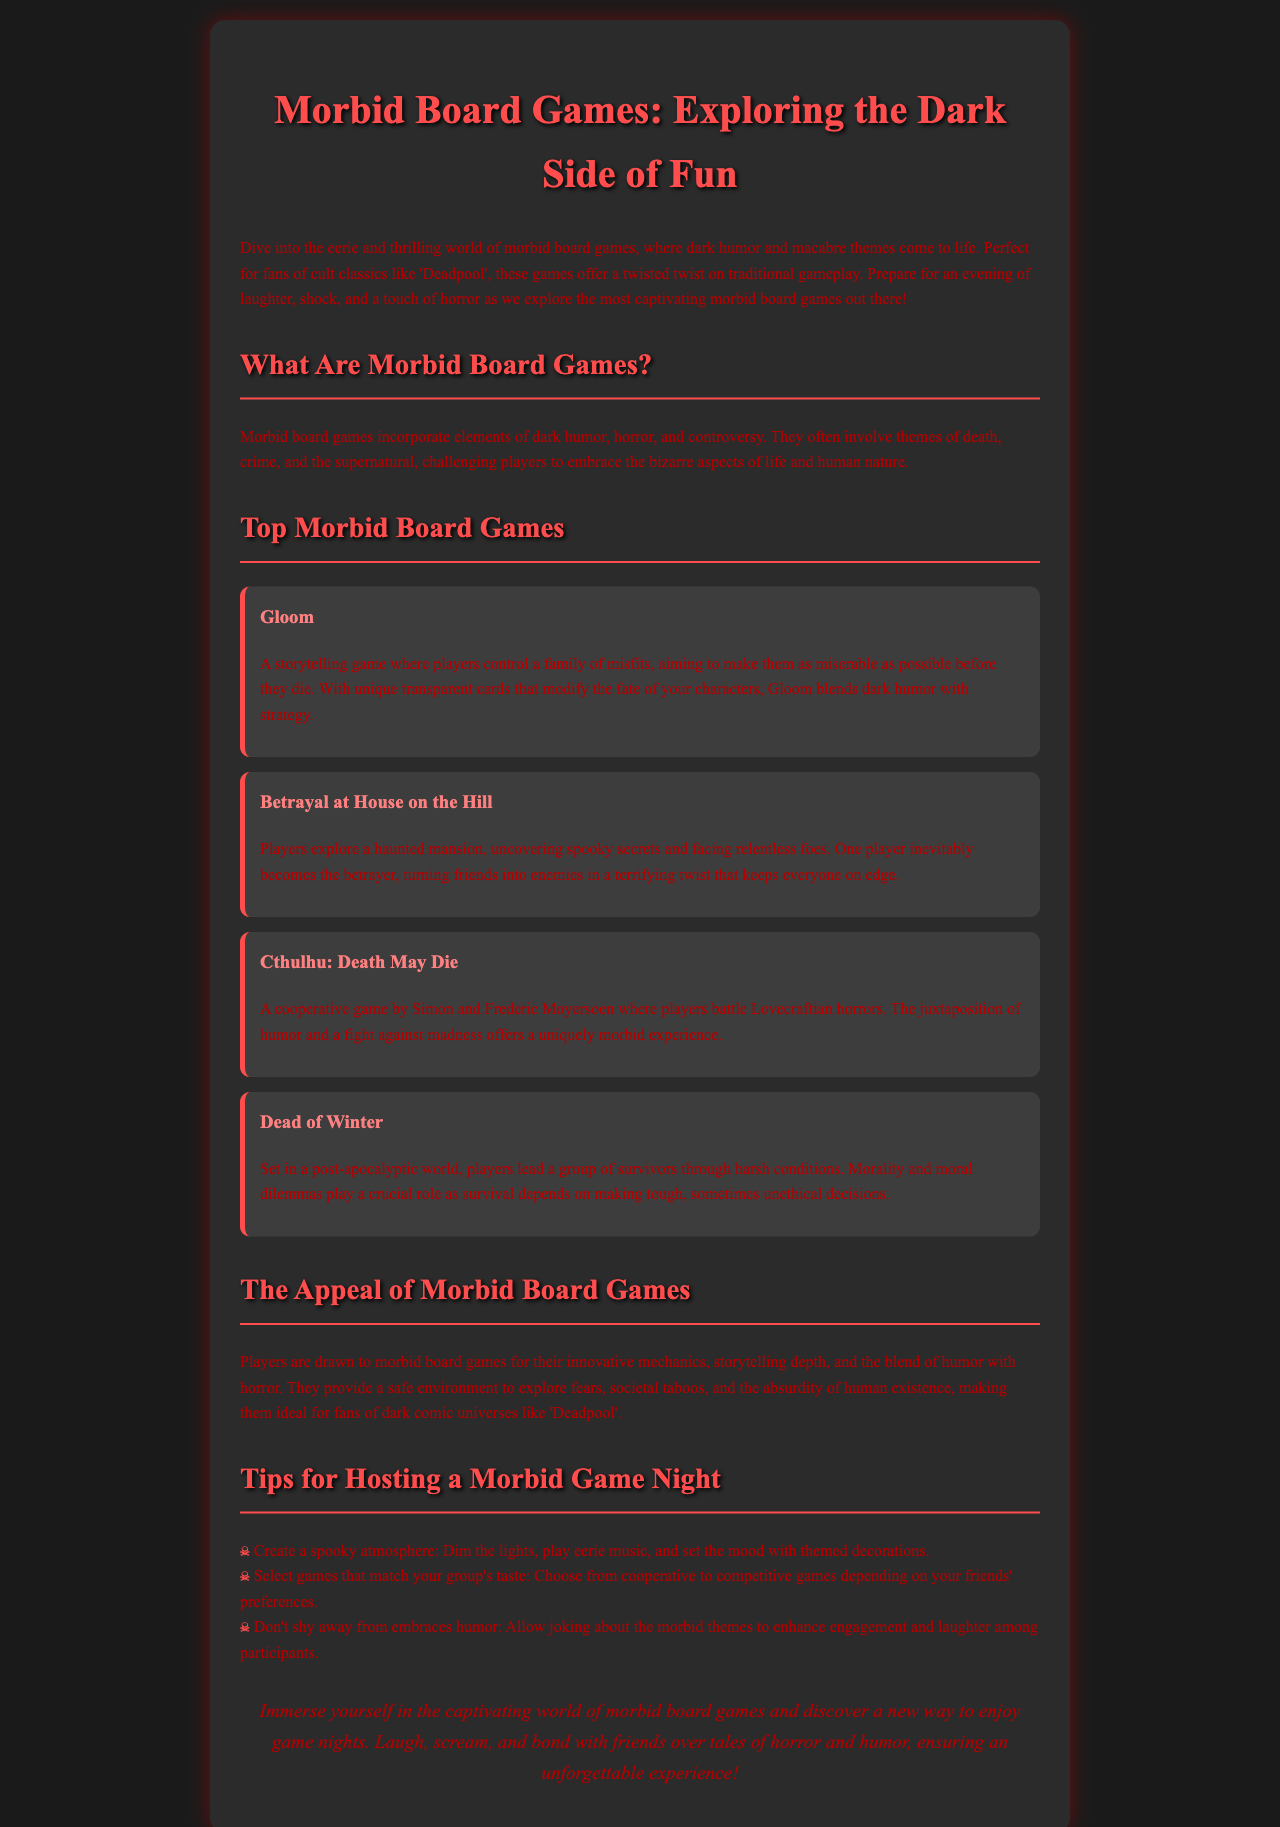What is the title of the brochure? The title of the brochure is the first heading in the document.
Answer: Morbid Board Games: Exploring the Dark Side of Fun What game involves making characters miserable? The game is mentioned in the section covering top morbid board games.
Answer: Gloom Which game features a haunted mansion? This game is discussed under the top morbid board games section focusing on betrayal.
Answer: Betrayal at House on the Hill How many top morbid board games are listed in the document? The total number of games listed can be counted in the "Top Morbid Board Games" section.
Answer: Four What is a suggested tip for hosting a morbid game night? A tip is provided as a bulleted list in the document.
Answer: Create a spooky atmosphere What type of themes do morbid board games incorporate? The document describes the themes in the section explaining what morbid board games are.
Answer: Dark humor What is one reason players are drawn to morbid board games? The document notes the appeal in the section describing the reasons for attraction to these games.
Answer: Innovative mechanics What does “Cthulhu: Death May Die” focus on? The focus of this game is mentioned in its description under top morbid board games.
Answer: Lovecraftian horrors What is a common element in morbid board games? This is outlined in the "What Are Morbid Board Games?" section regarding game themes.
Answer: Death 